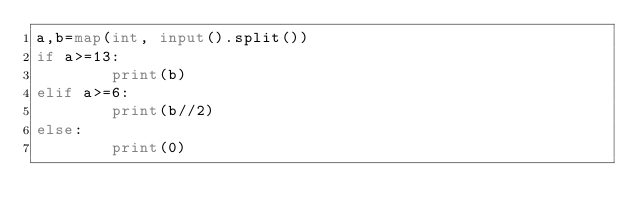<code> <loc_0><loc_0><loc_500><loc_500><_Python_>a,b=map(int, input().split())
if a>=13:
        print(b)
elif a>=6:
        print(b//2)
else:
        print(0)</code> 